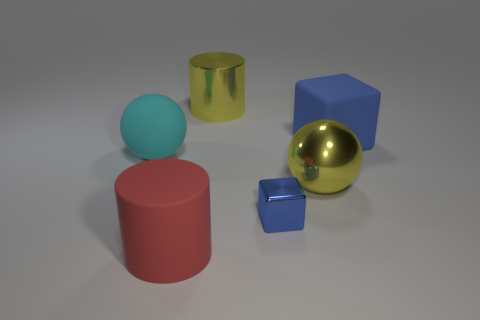Add 1 large shiny balls. How many objects exist? 7 Subtract all cyan balls. How many balls are left? 1 Add 6 small brown metal things. How many small brown metal things exist? 6 Subtract 0 blue balls. How many objects are left? 6 Subtract all blocks. How many objects are left? 4 Subtract 1 blocks. How many blocks are left? 1 Subtract all purple cubes. Subtract all blue cylinders. How many cubes are left? 2 Subtract all gray cylinders. How many red balls are left? 0 Subtract all small blue shiny cubes. Subtract all blue metallic blocks. How many objects are left? 4 Add 2 spheres. How many spheres are left? 4 